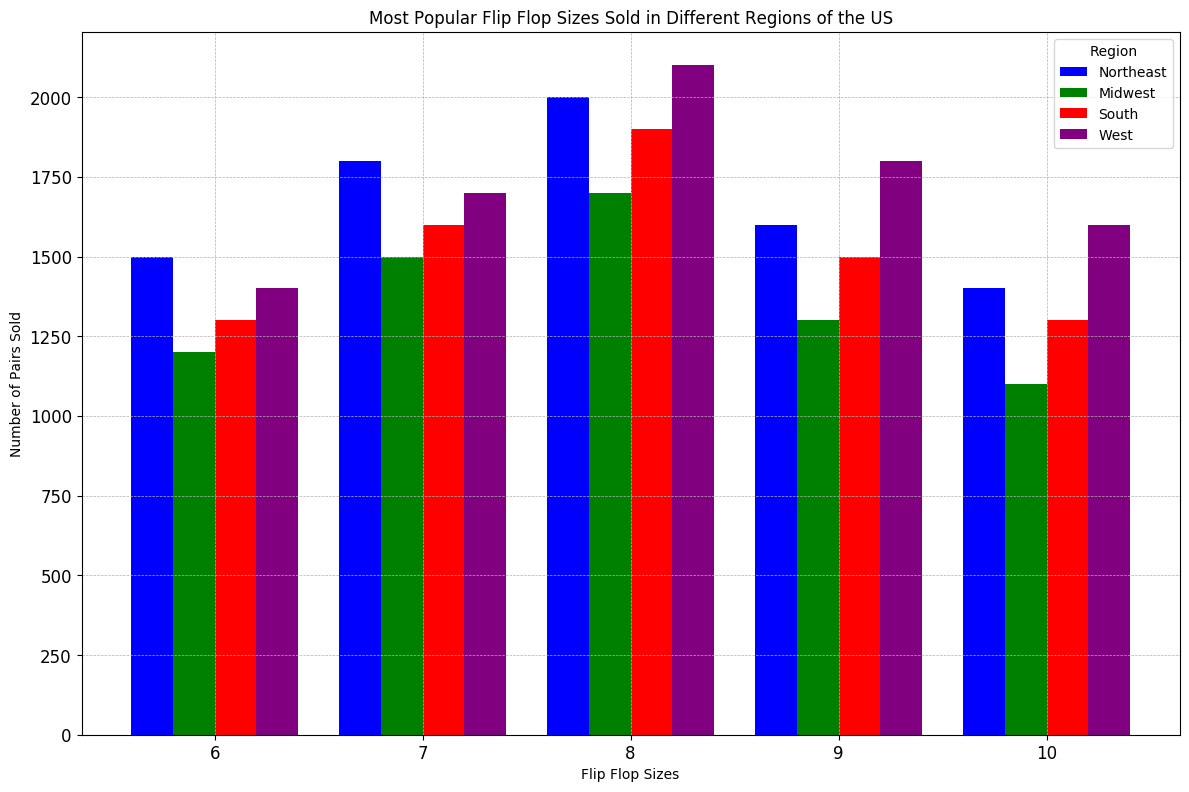Which region sold the most pairs of flip flops in size 8? Look at the bars representing size 8 across all regions. The bar for the West is the tallest in this size category.
Answer: West Which region has the least number of size 6 flip flops sold? Compare the bars representing size 6 across all regions. The Midwest has the shortest bar in this size category.
Answer: Midwest What is the total number of size 9 flip flops sold across all regions? Add the counts for size 9 from all regions: 1600 (Northeast) + 1300 (Midwest) + 1500 (South) + 1800 (West) = 6200.
Answer: 6200 Which region appears to have the greatest overall sales for all flip flop sizes? Sum the heights of the bars for each region. The West region consistently has taller bars overall compared to other regions.
Answer: West What is the average number of size 7 flip flops sold in the East and Midwest regions? Sum the number of size 7 flip flops sold in the Northeast (1800) and Midwest (1500), then divide by 2 to get the average: (1800 + 1500) / 2 = 1650.
Answer: 1650 Which flip flop size is the most popular in the South region? Observe the heights of bars for the South region. Size 8 has the tallest bar, indicating the highest count.
Answer: Size 8 Compare the sales of size 10 flip flops between the Northeast and the West. Which region sold more? Compare the heights of the bars for size 10 between the Northeast (1400) and the West (1600). The West has a taller bar.
Answer: West What is the difference in the number of size 8 flip flops sold between the West and the Midwest regions? Subtract the number of size 8 flip flops sold in the Midwest (1700) from the number sold in the West (2100): 2100 - 1700 = 400.
Answer: 400 How many more size 7 flip flops are sold in the South compared to the Midwest? Subtract the number of size 7 flip flops sold in the Midwest (1500) from the South (1600): 1600 - 1500 = 100.
Answer: 100 